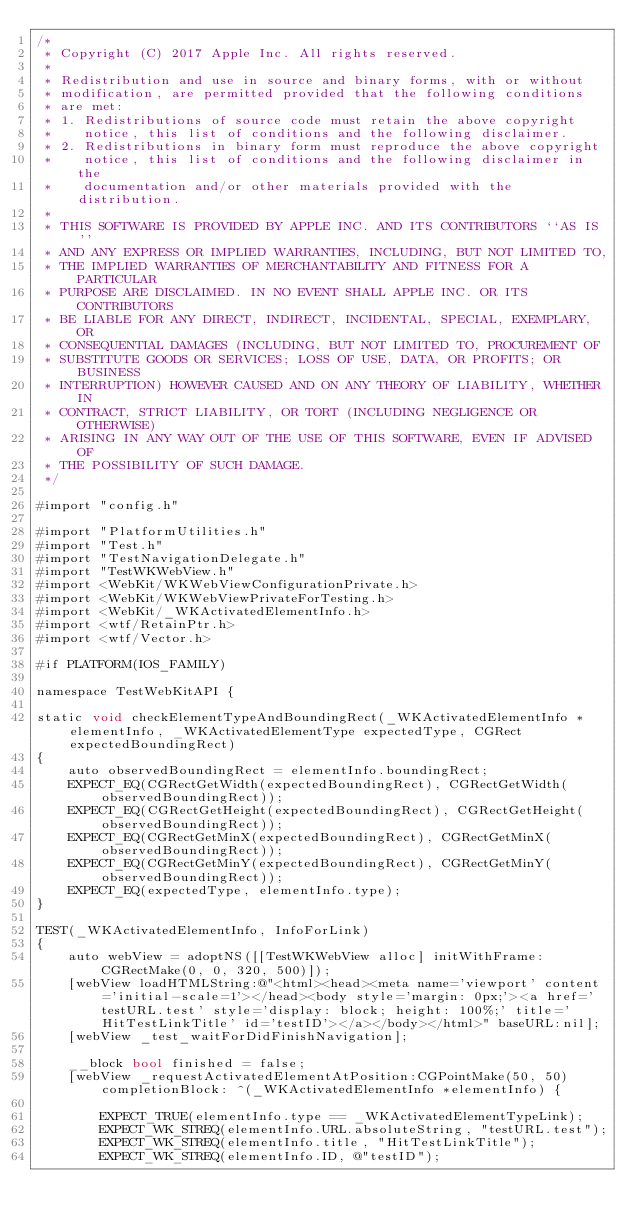Convert code to text. <code><loc_0><loc_0><loc_500><loc_500><_ObjectiveC_>/*
 * Copyright (C) 2017 Apple Inc. All rights reserved.
 *
 * Redistribution and use in source and binary forms, with or without
 * modification, are permitted provided that the following conditions
 * are met:
 * 1. Redistributions of source code must retain the above copyright
 *    notice, this list of conditions and the following disclaimer.
 * 2. Redistributions in binary form must reproduce the above copyright
 *    notice, this list of conditions and the following disclaimer in the
 *    documentation and/or other materials provided with the distribution.
 *
 * THIS SOFTWARE IS PROVIDED BY APPLE INC. AND ITS CONTRIBUTORS ``AS IS''
 * AND ANY EXPRESS OR IMPLIED WARRANTIES, INCLUDING, BUT NOT LIMITED TO,
 * THE IMPLIED WARRANTIES OF MERCHANTABILITY AND FITNESS FOR A PARTICULAR
 * PURPOSE ARE DISCLAIMED. IN NO EVENT SHALL APPLE INC. OR ITS CONTRIBUTORS
 * BE LIABLE FOR ANY DIRECT, INDIRECT, INCIDENTAL, SPECIAL, EXEMPLARY, OR
 * CONSEQUENTIAL DAMAGES (INCLUDING, BUT NOT LIMITED TO, PROCUREMENT OF
 * SUBSTITUTE GOODS OR SERVICES; LOSS OF USE, DATA, OR PROFITS; OR BUSINESS
 * INTERRUPTION) HOWEVER CAUSED AND ON ANY THEORY OF LIABILITY, WHETHER IN
 * CONTRACT, STRICT LIABILITY, OR TORT (INCLUDING NEGLIGENCE OR OTHERWISE)
 * ARISING IN ANY WAY OUT OF THE USE OF THIS SOFTWARE, EVEN IF ADVISED OF
 * THE POSSIBILITY OF SUCH DAMAGE.
 */

#import "config.h"

#import "PlatformUtilities.h"
#import "Test.h"
#import "TestNavigationDelegate.h"
#import "TestWKWebView.h"
#import <WebKit/WKWebViewConfigurationPrivate.h>
#import <WebKit/WKWebViewPrivateForTesting.h>
#import <WebKit/_WKActivatedElementInfo.h>
#import <wtf/RetainPtr.h>
#import <wtf/Vector.h>

#if PLATFORM(IOS_FAMILY)

namespace TestWebKitAPI {

static void checkElementTypeAndBoundingRect(_WKActivatedElementInfo *elementInfo, _WKActivatedElementType expectedType, CGRect expectedBoundingRect)
{
    auto observedBoundingRect = elementInfo.boundingRect;
    EXPECT_EQ(CGRectGetWidth(expectedBoundingRect), CGRectGetWidth(observedBoundingRect));
    EXPECT_EQ(CGRectGetHeight(expectedBoundingRect), CGRectGetHeight(observedBoundingRect));
    EXPECT_EQ(CGRectGetMinX(expectedBoundingRect), CGRectGetMinX(observedBoundingRect));
    EXPECT_EQ(CGRectGetMinY(expectedBoundingRect), CGRectGetMinY(observedBoundingRect));
    EXPECT_EQ(expectedType, elementInfo.type);
}

TEST(_WKActivatedElementInfo, InfoForLink)
{
    auto webView = adoptNS([[TestWKWebView alloc] initWithFrame:CGRectMake(0, 0, 320, 500)]);
    [webView loadHTMLString:@"<html><head><meta name='viewport' content='initial-scale=1'></head><body style='margin: 0px;'><a href='testURL.test' style='display: block; height: 100%;' title='HitTestLinkTitle' id='testID'></a></body></html>" baseURL:nil];
    [webView _test_waitForDidFinishNavigation];

    __block bool finished = false;
    [webView _requestActivatedElementAtPosition:CGPointMake(50, 50) completionBlock: ^(_WKActivatedElementInfo *elementInfo) {

        EXPECT_TRUE(elementInfo.type == _WKActivatedElementTypeLink);
        EXPECT_WK_STREQ(elementInfo.URL.absoluteString, "testURL.test");
        EXPECT_WK_STREQ(elementInfo.title, "HitTestLinkTitle");
        EXPECT_WK_STREQ(elementInfo.ID, @"testID");</code> 